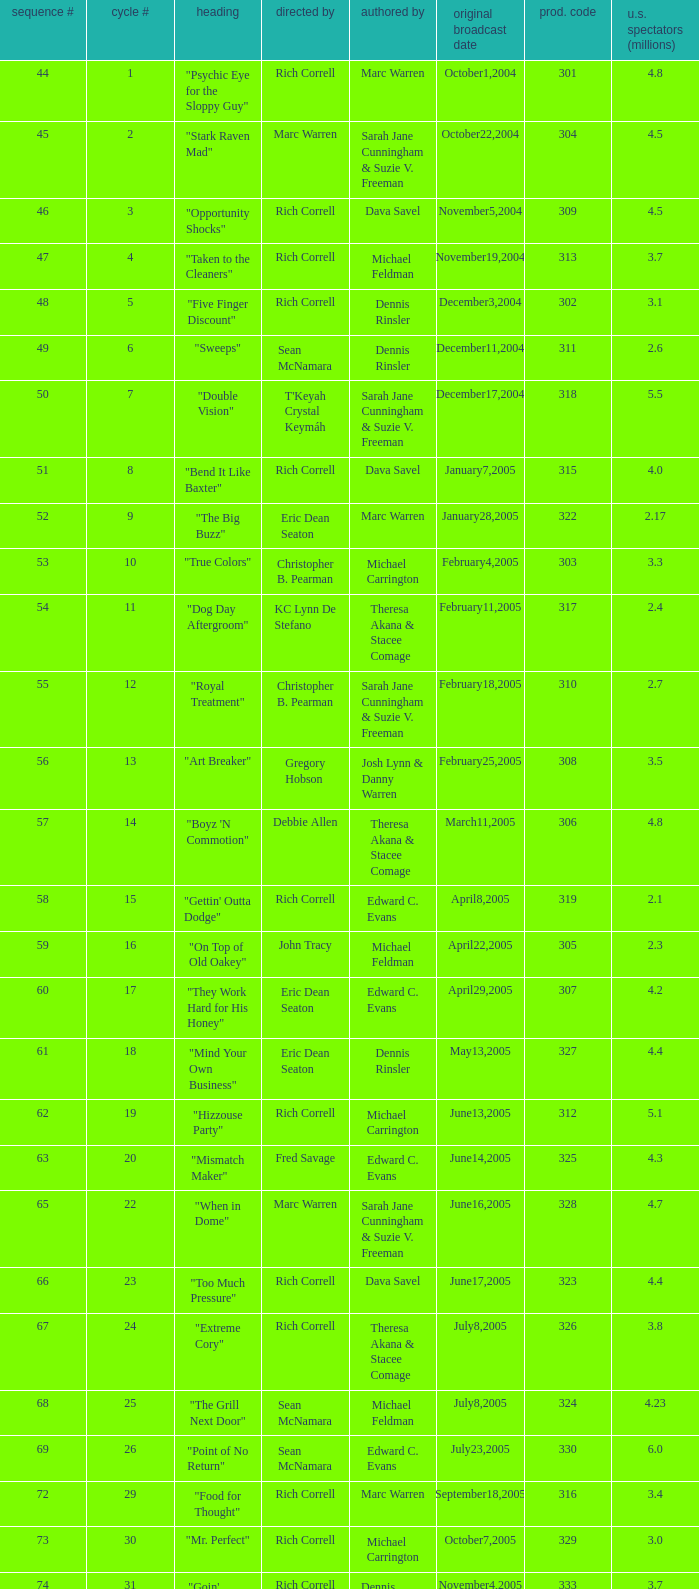What was the production code of the episode directed by Rondell Sheridan?  332.0. 